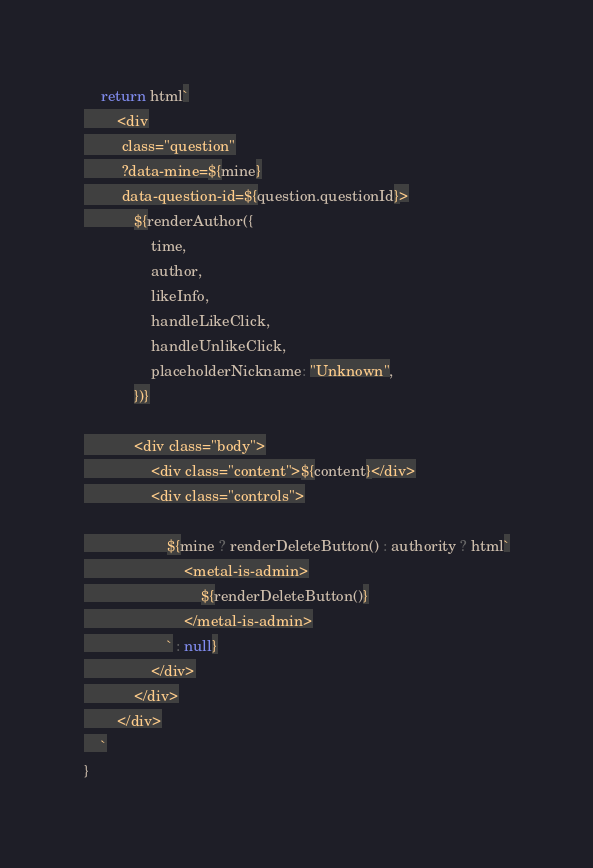Convert code to text. <code><loc_0><loc_0><loc_500><loc_500><_TypeScript_>
	return html`
		<div
		 class="question"
		 ?data-mine=${mine}
		 data-question-id=${question.questionId}>
			${renderAuthor({
				time,
				author,
				likeInfo,
				handleLikeClick,
				handleUnlikeClick,
				placeholderNickname: "Unknown",
			})}

			<div class="body">
				<div class="content">${content}</div>
				<div class="controls">

					${mine ? renderDeleteButton() : authority ? html`
						<metal-is-admin>
							${renderDeleteButton()}
						</metal-is-admin>
					` : null}
				</div>
			</div>
		</div>
	`
}
</code> 